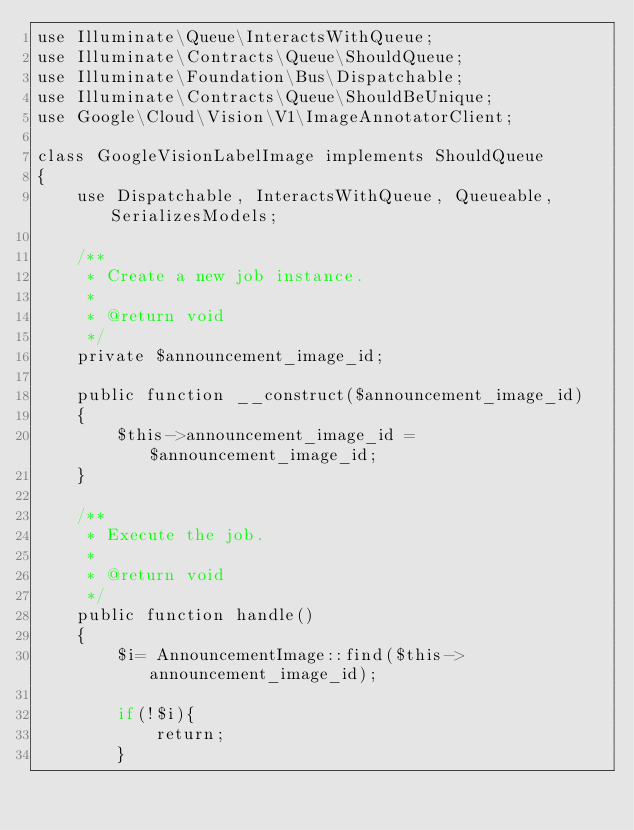<code> <loc_0><loc_0><loc_500><loc_500><_PHP_>use Illuminate\Queue\InteractsWithQueue;
use Illuminate\Contracts\Queue\ShouldQueue;
use Illuminate\Foundation\Bus\Dispatchable;
use Illuminate\Contracts\Queue\ShouldBeUnique;
use Google\Cloud\Vision\V1\ImageAnnotatorClient;

class GoogleVisionLabelImage implements ShouldQueue
{
    use Dispatchable, InteractsWithQueue, Queueable, SerializesModels;

    /**
     * Create a new job instance.
     *
     * @return void
     */
    private $announcement_image_id;

    public function __construct($announcement_image_id)
    {
        $this->announcement_image_id =$announcement_image_id;
    }

    /**
     * Execute the job.
     *
     * @return void
     */
    public function handle()
    {
        $i= AnnouncementImage::find($this->announcement_image_id);

        if(!$i){
            return;
        }
</code> 